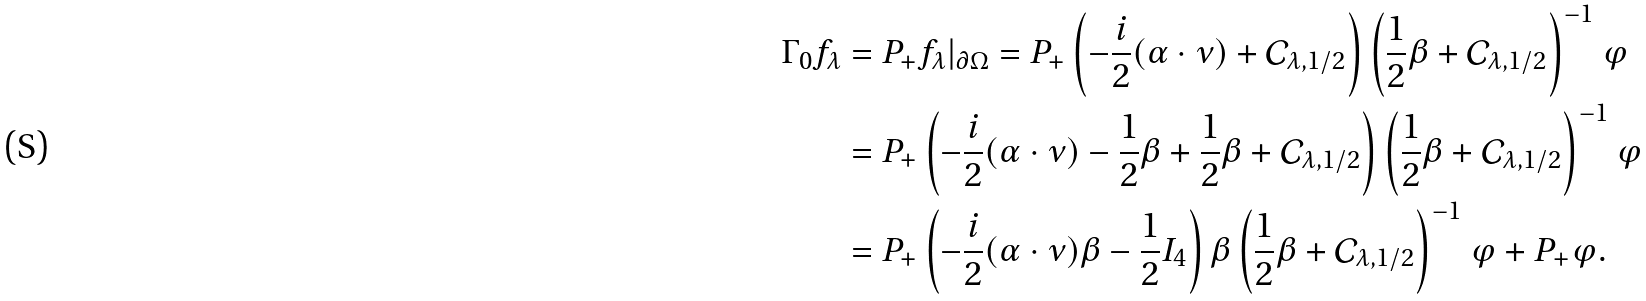<formula> <loc_0><loc_0><loc_500><loc_500>\Gamma _ { 0 } f _ { \lambda } & = P _ { + } f _ { \lambda } | _ { \partial \Omega } = P _ { + } \left ( - \frac { i } { 2 } ( \alpha \cdot \nu ) + \mathcal { C } _ { \lambda , 1 / 2 } \right ) \left ( \frac { 1 } { 2 } \beta + \mathcal { C } _ { \lambda , 1 / 2 } \right ) ^ { - 1 } \varphi \\ & = P _ { + } \left ( - \frac { i } { 2 } ( \alpha \cdot \nu ) - \frac { 1 } { 2 } \beta + \frac { 1 } { 2 } \beta + \mathcal { C } _ { \lambda , 1 / 2 } \right ) \left ( \frac { 1 } { 2 } \beta + \mathcal { C } _ { \lambda , 1 / 2 } \right ) ^ { - 1 } \varphi \\ & = P _ { + } \left ( - \frac { i } { 2 } ( \alpha \cdot \nu ) \beta - \frac { 1 } { 2 } I _ { 4 } \right ) \beta \left ( \frac { 1 } { 2 } \beta + \mathcal { C } _ { \lambda , 1 / 2 } \right ) ^ { - 1 } \varphi + P _ { + } \varphi .</formula> 